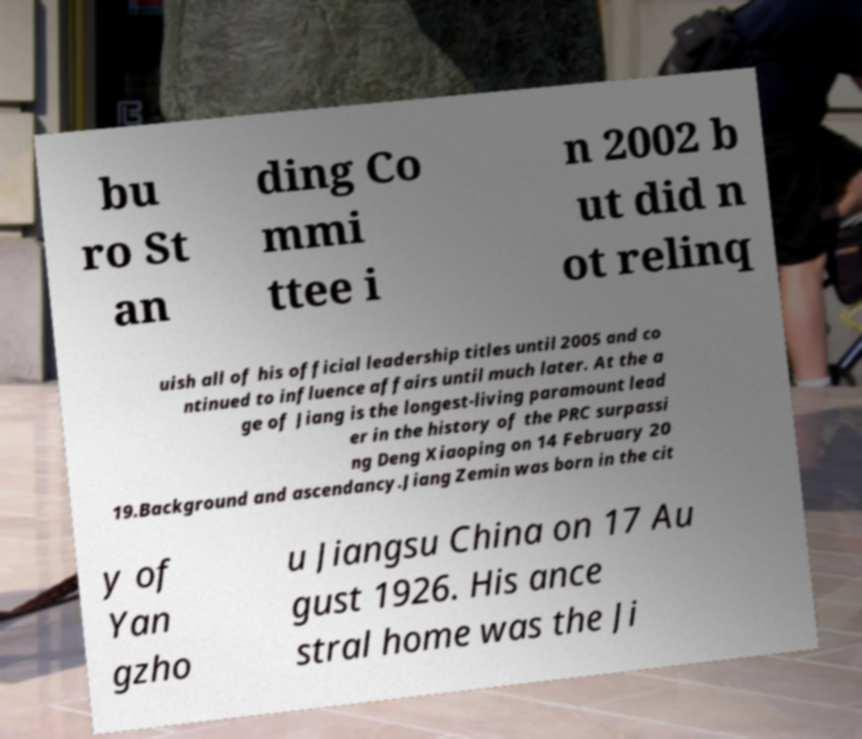Please identify and transcribe the text found in this image. bu ro St an ding Co mmi ttee i n 2002 b ut did n ot relinq uish all of his official leadership titles until 2005 and co ntinued to influence affairs until much later. At the a ge of Jiang is the longest-living paramount lead er in the history of the PRC surpassi ng Deng Xiaoping on 14 February 20 19.Background and ascendancy.Jiang Zemin was born in the cit y of Yan gzho u Jiangsu China on 17 Au gust 1926. His ance stral home was the Ji 